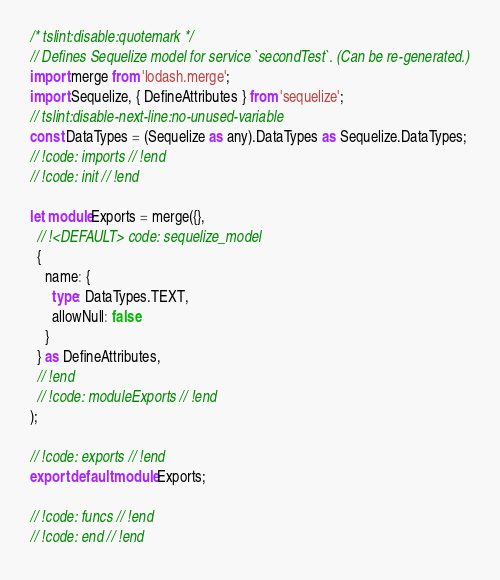<code> <loc_0><loc_0><loc_500><loc_500><_TypeScript_>
/* tslint:disable:quotemark */
// Defines Sequelize model for service `secondTest`. (Can be re-generated.)
import merge from 'lodash.merge';
import Sequelize, { DefineAttributes } from 'sequelize';
// tslint:disable-next-line:no-unused-variable
const DataTypes = (Sequelize as any).DataTypes as Sequelize.DataTypes;
// !code: imports // !end
// !code: init // !end

let moduleExports = merge({},
  // !<DEFAULT> code: sequelize_model
  {
    name: {
      type: DataTypes.TEXT,
      allowNull: false
    }
  } as DefineAttributes,
  // !end
  // !code: moduleExports // !end
);

// !code: exports // !end
export default moduleExports;

// !code: funcs // !end
// !code: end // !end
</code> 